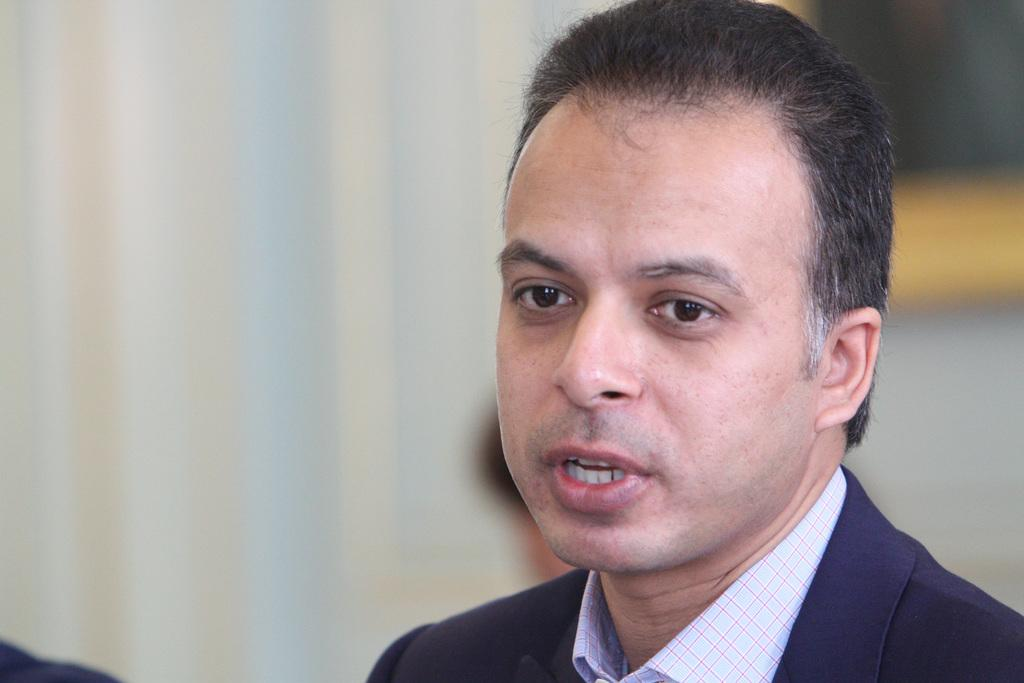Who is present in the image? There is a man in the image. What is the man wearing? The man is wearing a navy blue coat. Can you describe the background of the image? The background of the image is blurred. What is the position of the airport in the image? There is no airport present in the image. Does the existence of the man in the image imply the existence of a specific location or event? The presence of the man in the image does not necessarily imply the existence of a specific location or event. 